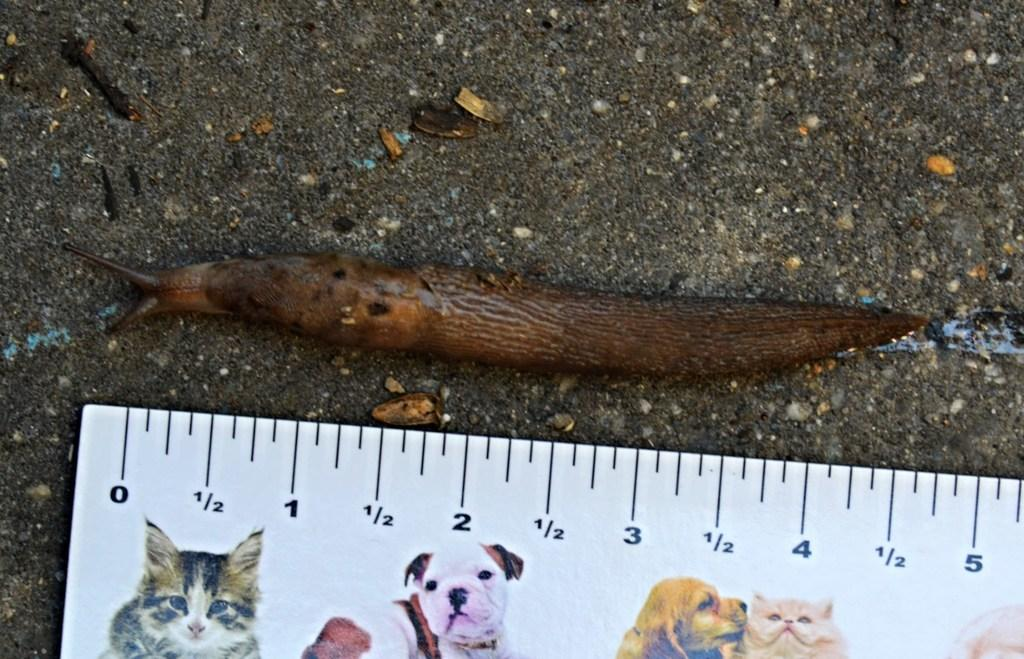What type of animal is present in the picture? There is a snail in the picture. What object is also visible in the picture? There is a scale in the picture. What images are displayed on the scale? The scale has pictures of a cat and a dog on it. What type of plantation can be seen in the background of the image? There is no plantation present in the image; it only features a snail, a scale, and pictures of a cat and a dog. 